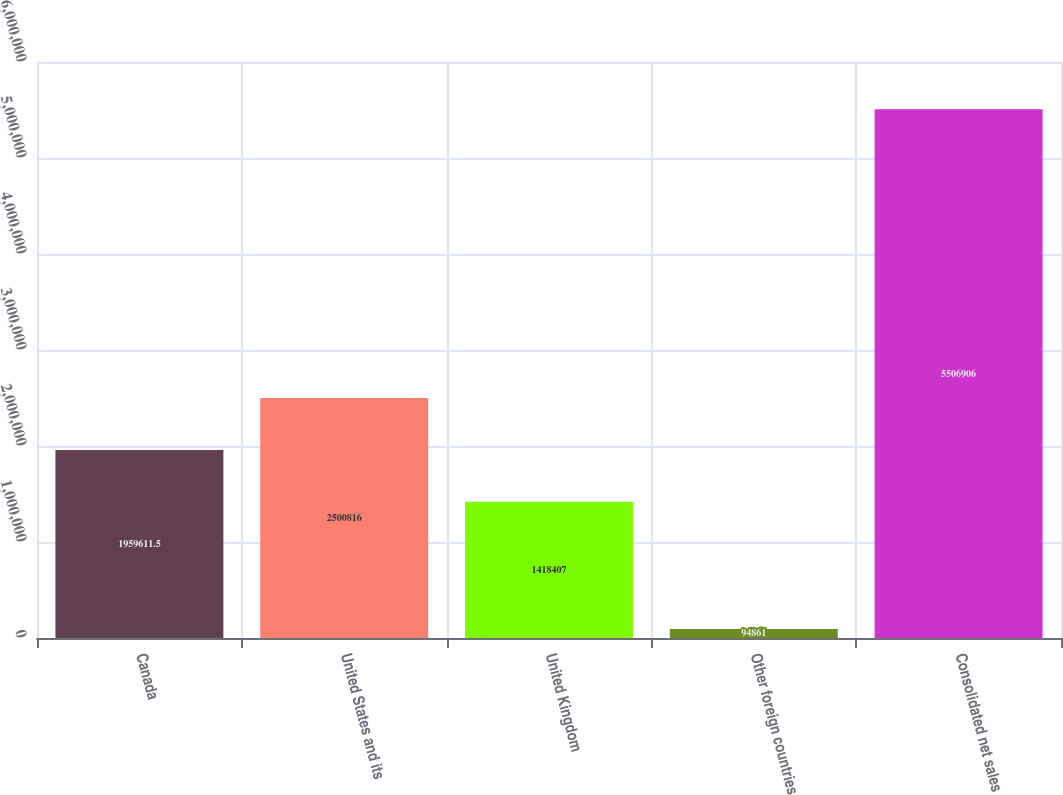Convert chart. <chart><loc_0><loc_0><loc_500><loc_500><bar_chart><fcel>Canada<fcel>United States and its<fcel>United Kingdom<fcel>Other foreign countries<fcel>Consolidated net sales<nl><fcel>1.95961e+06<fcel>2.50082e+06<fcel>1.41841e+06<fcel>94861<fcel>5.50691e+06<nl></chart> 